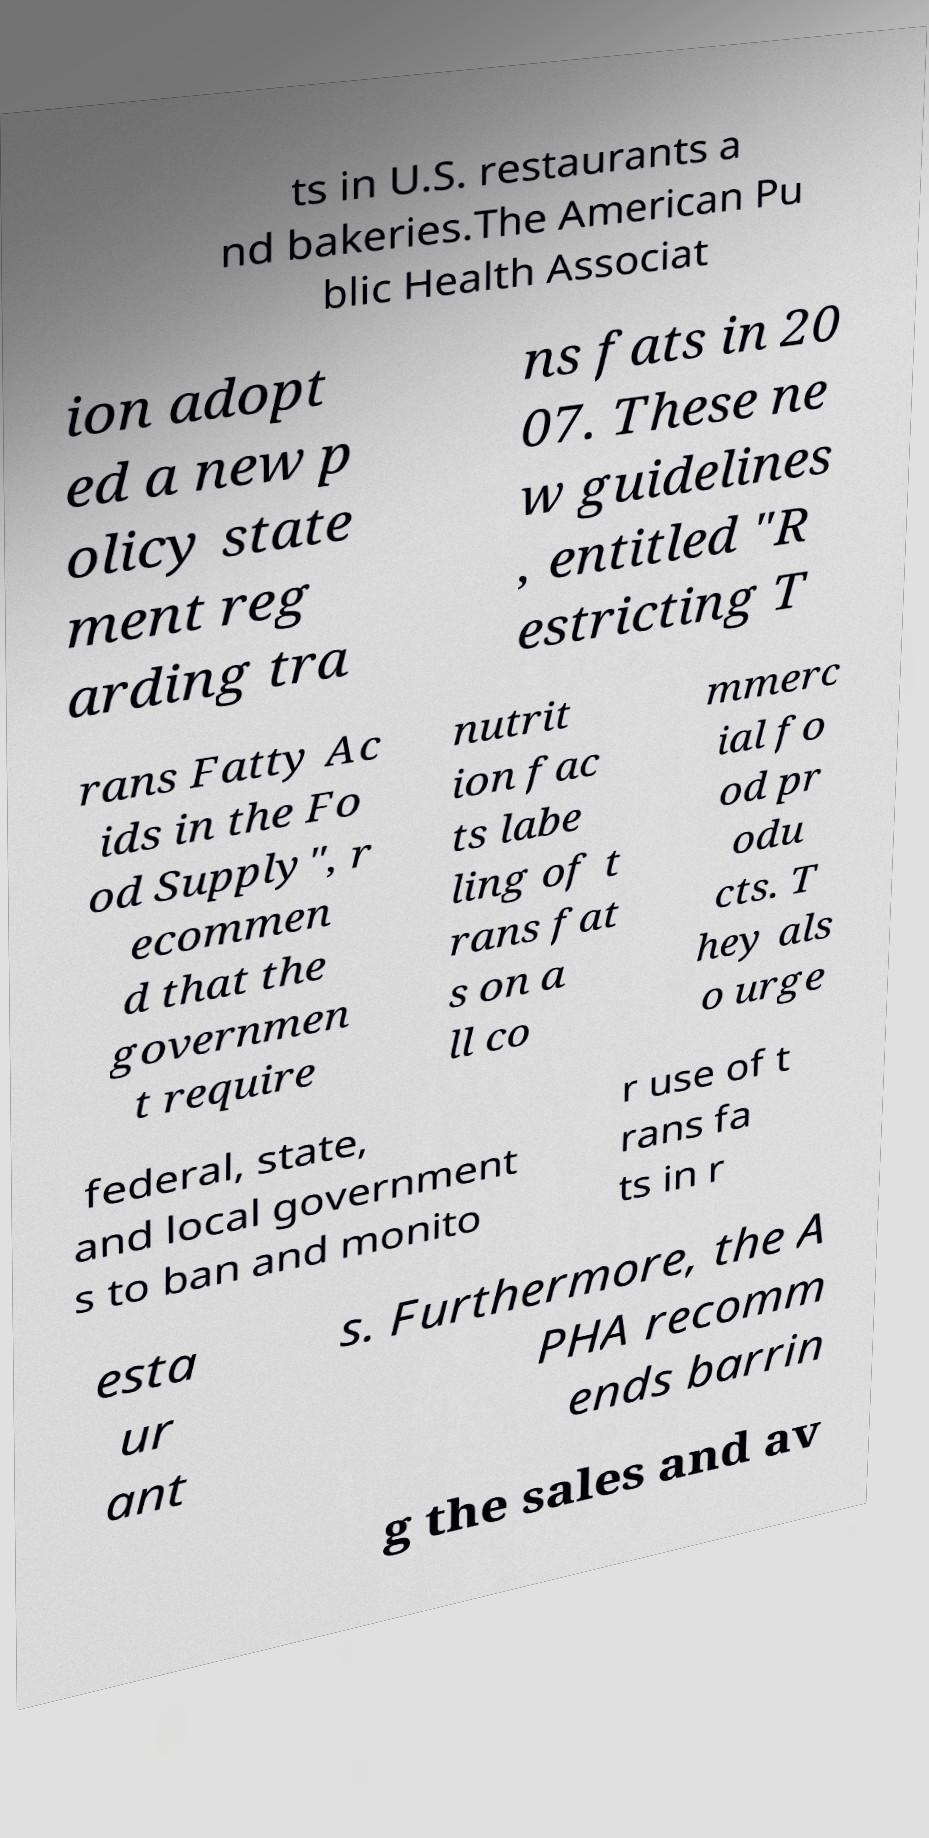Please identify and transcribe the text found in this image. ts in U.S. restaurants a nd bakeries.The American Pu blic Health Associat ion adopt ed a new p olicy state ment reg arding tra ns fats in 20 07. These ne w guidelines , entitled "R estricting T rans Fatty Ac ids in the Fo od Supply", r ecommen d that the governmen t require nutrit ion fac ts labe ling of t rans fat s on a ll co mmerc ial fo od pr odu cts. T hey als o urge federal, state, and local government s to ban and monito r use of t rans fa ts in r esta ur ant s. Furthermore, the A PHA recomm ends barrin g the sales and av 